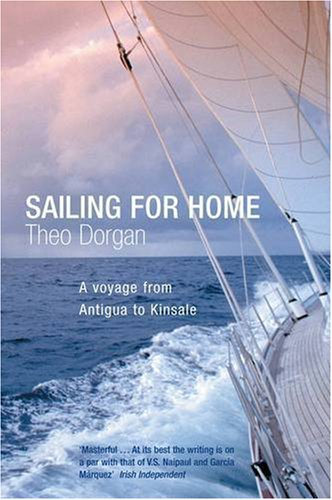Describe the scene depicted on the book cover. The cover shows a captivating oceanic scene, viewed from the deck of a sailing boat with the sails in view and a dramatic sky, portraying the allure and challenge of sea voyages. 